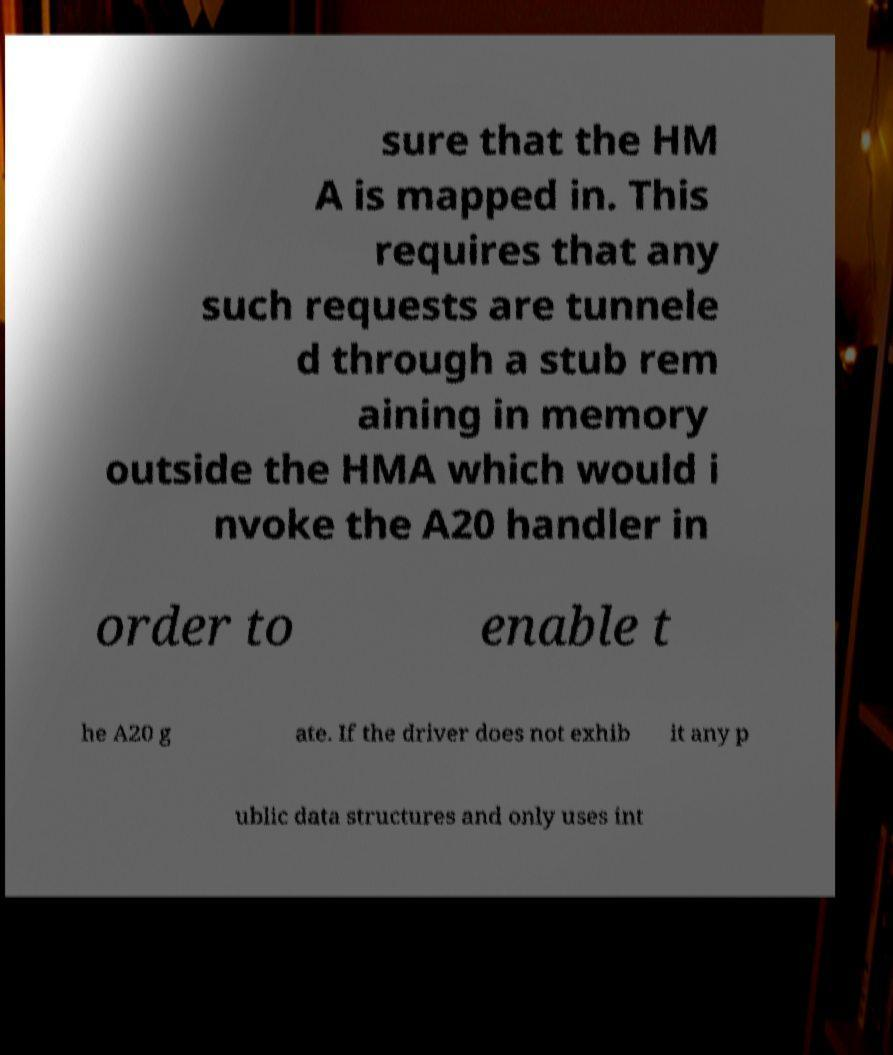Can you read and provide the text displayed in the image?This photo seems to have some interesting text. Can you extract and type it out for me? sure that the HM A is mapped in. This requires that any such requests are tunnele d through a stub rem aining in memory outside the HMA which would i nvoke the A20 handler in order to enable t he A20 g ate. If the driver does not exhib it any p ublic data structures and only uses int 